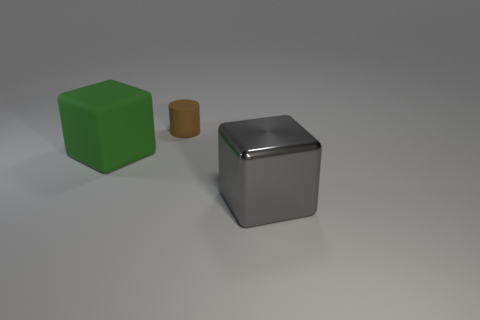Are there any other things that are the same size as the shiny block?
Give a very brief answer. Yes. There is a cube in front of the large green rubber cube; what is its color?
Provide a short and direct response. Gray. There is a thing that is behind the big green cube that is left of the brown rubber object that is left of the metal block; what is its material?
Your answer should be compact. Rubber. How big is the matte object that is to the right of the rubber block that is left of the large gray cube?
Provide a short and direct response. Small. There is a big metallic object that is the same shape as the big green matte object; what is its color?
Provide a short and direct response. Gray. Do the rubber block and the brown object have the same size?
Keep it short and to the point. No. What material is the tiny brown cylinder?
Ensure brevity in your answer.  Rubber. There is a thing that is made of the same material as the big green cube; what is its color?
Your answer should be very brief. Brown. Is the small brown object made of the same material as the block to the right of the green rubber thing?
Keep it short and to the point. No. How many tiny brown objects have the same material as the big green thing?
Make the answer very short. 1. 